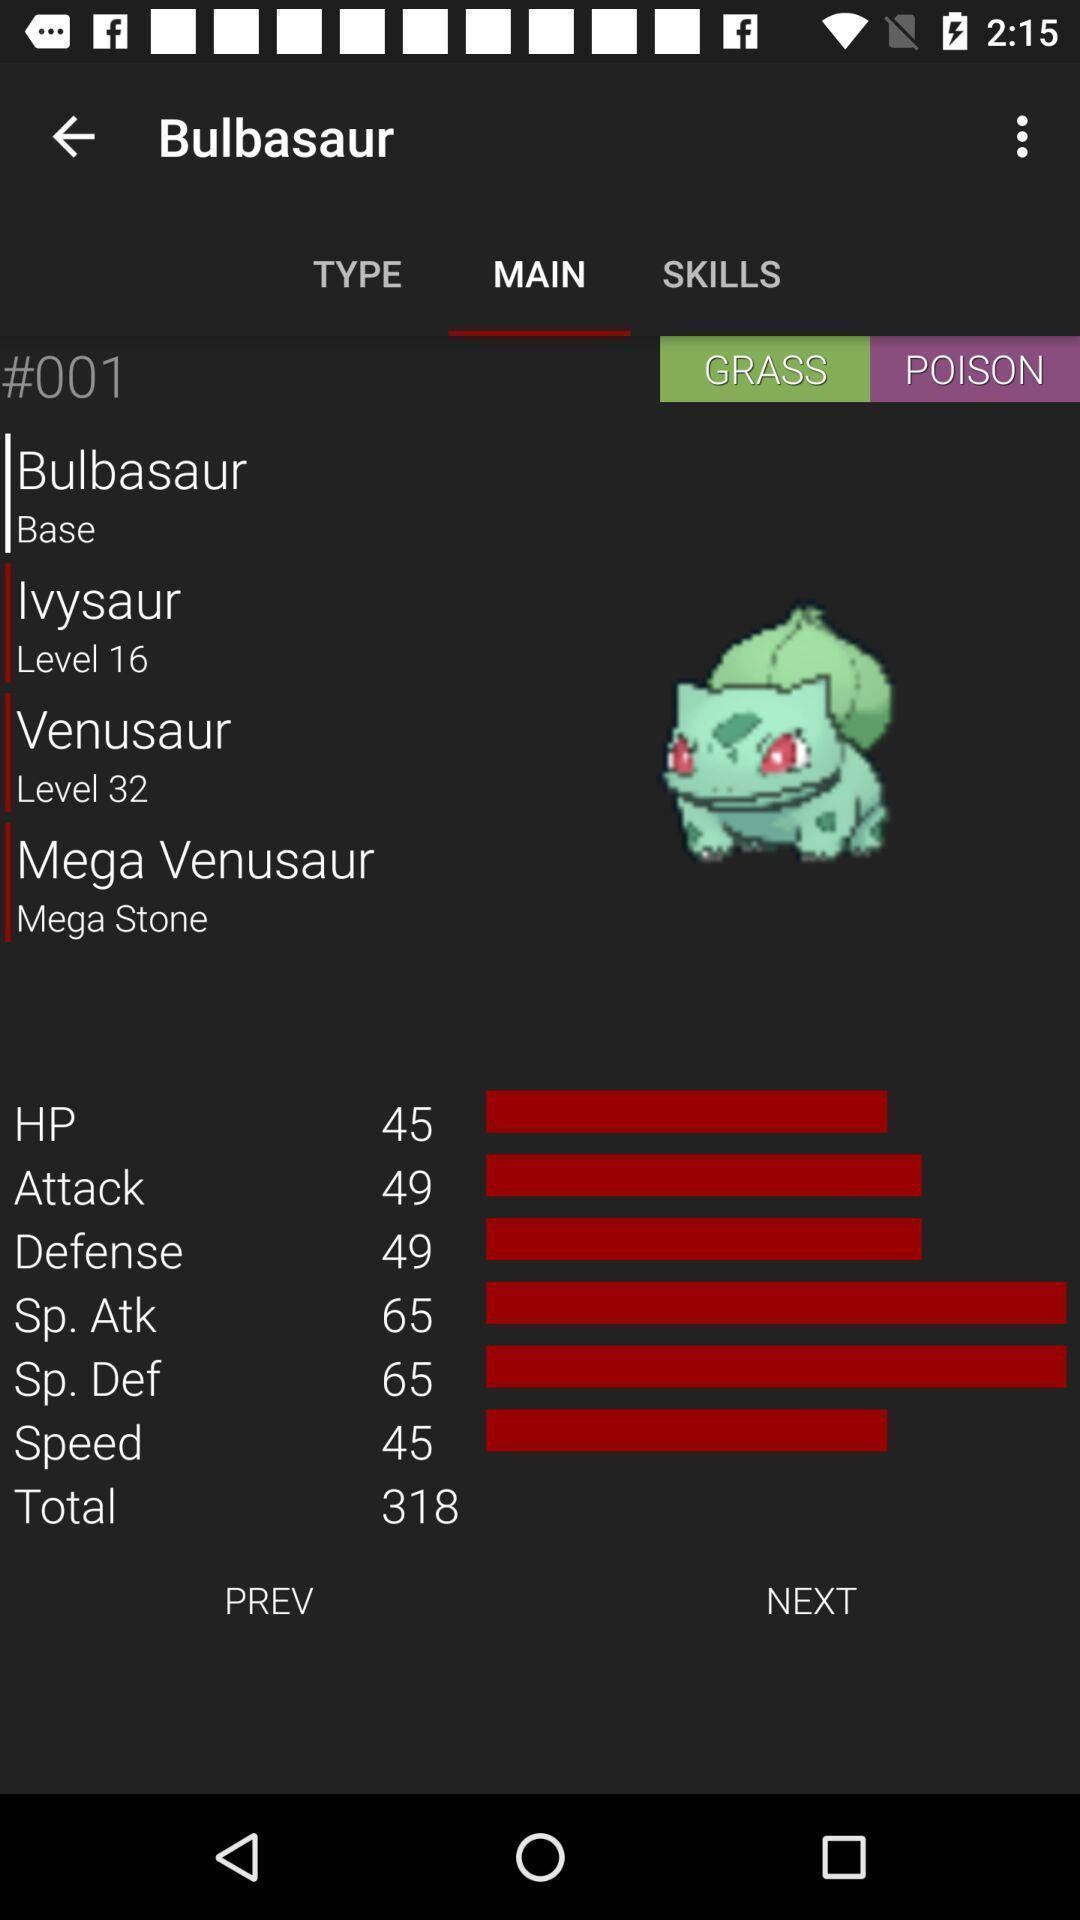What details can you identify in this image? Screen showing details of a pokemon. 